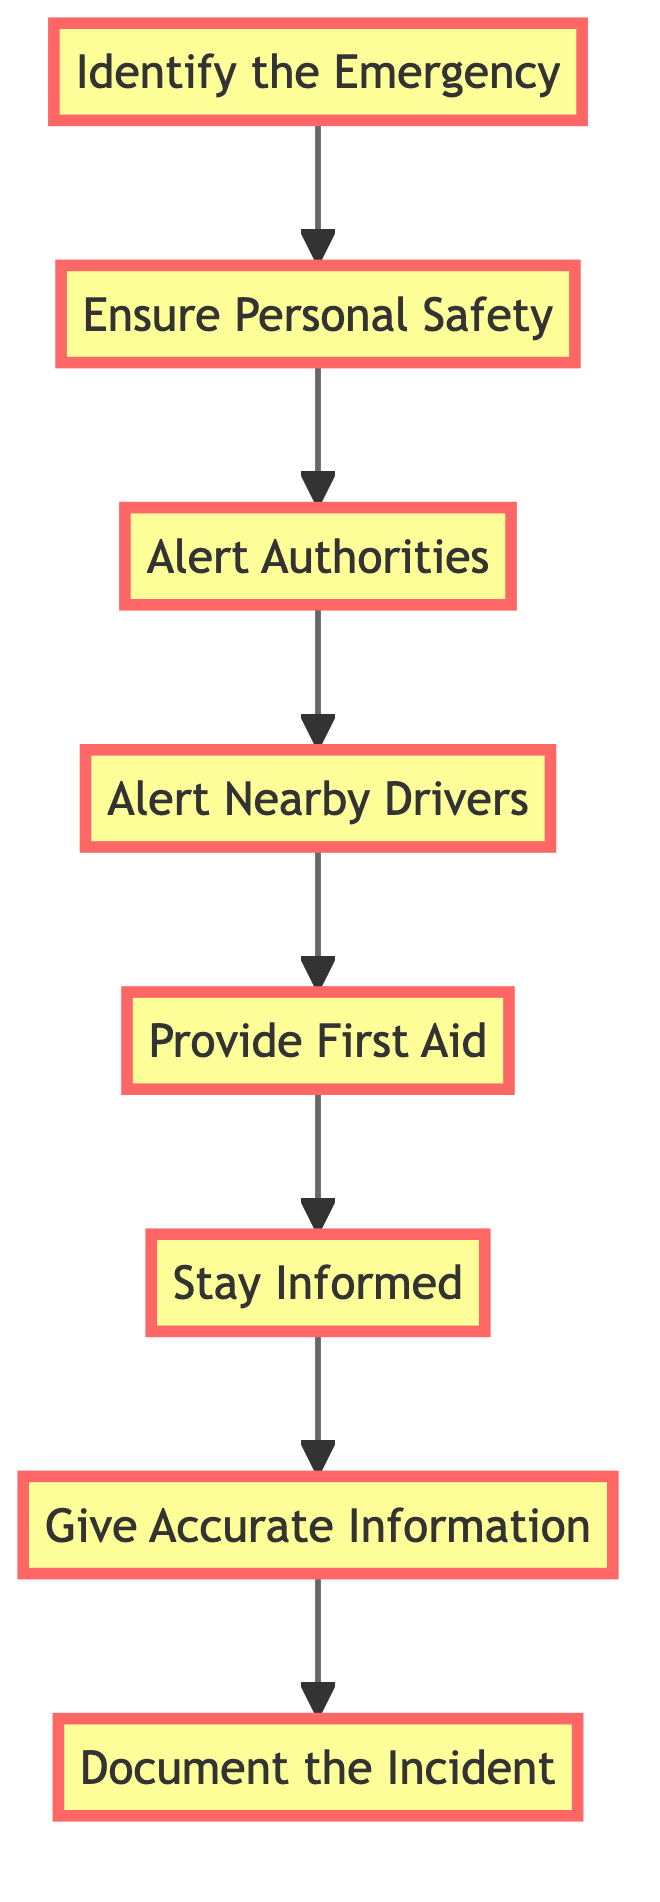What is the first step in the emergency response process? The first step is identified in the diagram as "Identify the Emergency," which is the initial action that needs to be taken.
Answer: Identify the Emergency How many nodes are there in the diagram? The diagram contains a total of 8 nodes, each representing a different step in the emergency response process.
Answer: 8 What comes after "Ensure Personal Safety"? Following "Ensure Personal Safety," the next step in the diagram is "Alert Authorities" which is the process to notify the emergency services.
Answer: Alert Authorities What is the last action mentioned in the diagram? The last action stated in the diagram is "Document the Incident," marking the final step of the emergency response process.
Answer: Document the Incident Which step involves alerting other drivers? The diagram clearly indicates that "Alert Nearby Drivers" is the step that involves notifying other drivers of the situation using various signals.
Answer: Alert Nearby Drivers Is "Provide First Aid" before or after "Stay Informed"? The flow of the diagram shows that "Provide First Aid" is before "Stay Informed," indicating the order of actions during an emergency response.
Answer: Before What action must be taken if you're trained and someone is injured? According to the diagram, if trained, the action to take is "Provide First Aid" to assist anyone injured until professionals arrive.
Answer: Provide First Aid How does one provide a clear description of the emergency? In the sequence of the diagram, "Give Accurate Information" is the step where one should provide a clear description of the emergency to arriving authorities.
Answer: Give Accurate Information What relationship exists between "Alert Authorities" and "Alert Nearby Drivers"? The relationship in the diagram indicates that "Alert Authorities" leads to "Alert Nearby Drivers," suggesting that notifying authorities is a prerequisite to alerting nearby vehicles.
Answer: Next 